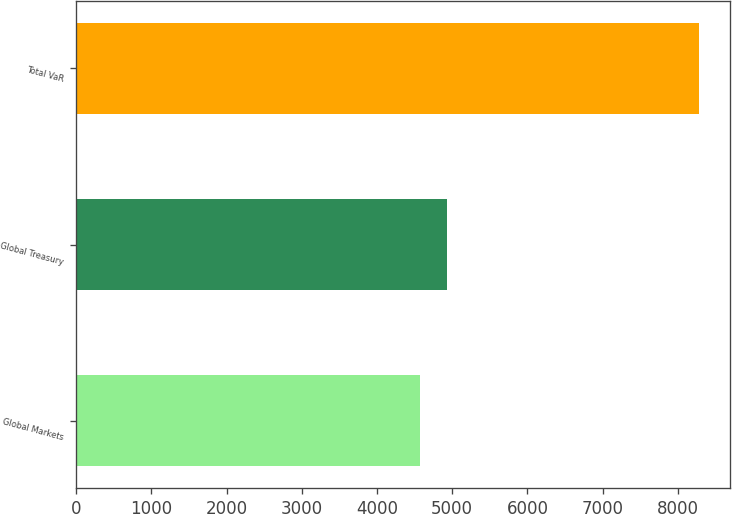<chart> <loc_0><loc_0><loc_500><loc_500><bar_chart><fcel>Global Markets<fcel>Global Treasury<fcel>Total VaR<nl><fcel>4566<fcel>4937.5<fcel>8281<nl></chart> 